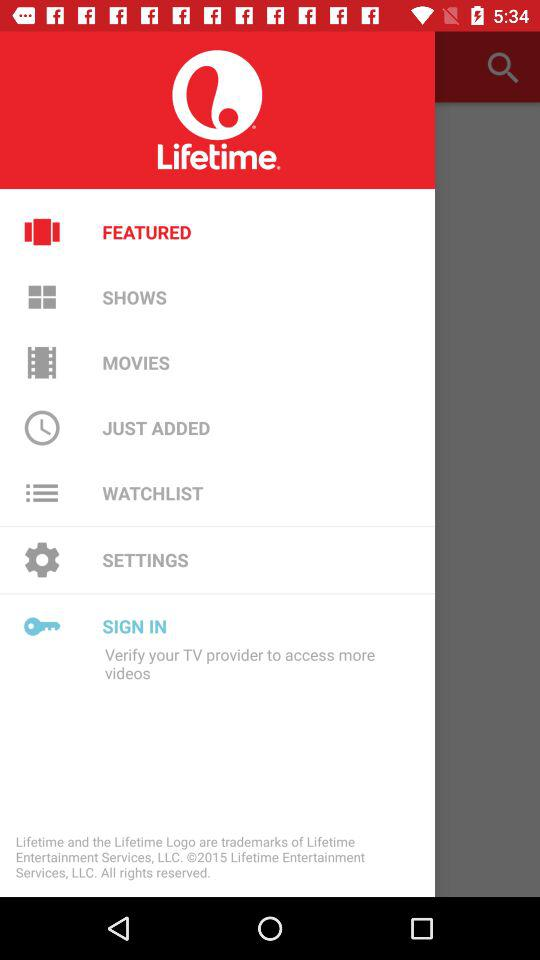How many notifications are there in "SHOWS"?
When the provided information is insufficient, respond with <no answer>. <no answer> 